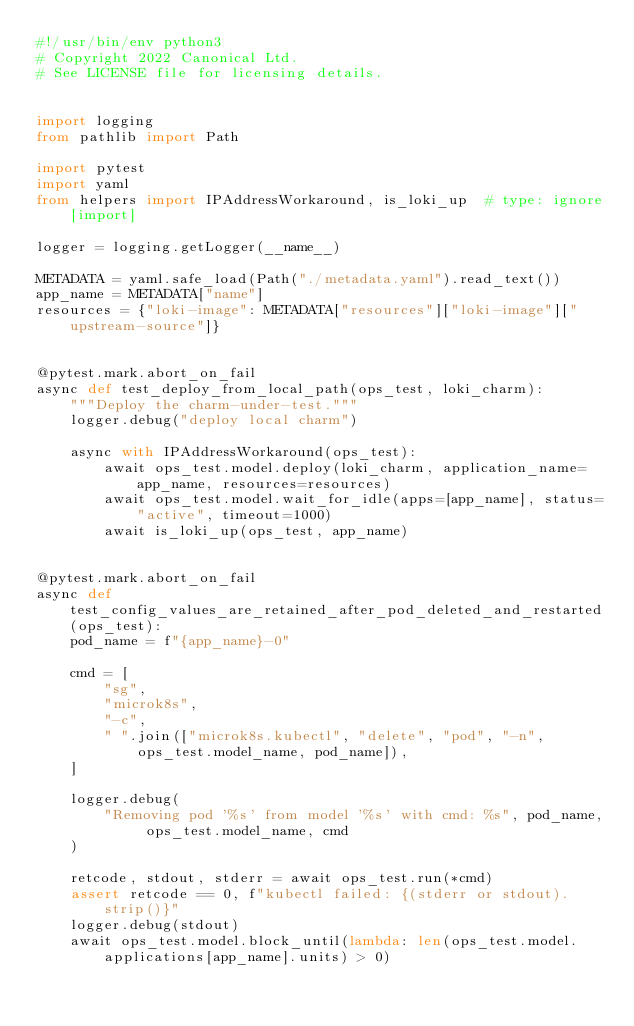Convert code to text. <code><loc_0><loc_0><loc_500><loc_500><_Python_>#!/usr/bin/env python3
# Copyright 2022 Canonical Ltd.
# See LICENSE file for licensing details.


import logging
from pathlib import Path

import pytest
import yaml
from helpers import IPAddressWorkaround, is_loki_up  # type: ignore[import]

logger = logging.getLogger(__name__)

METADATA = yaml.safe_load(Path("./metadata.yaml").read_text())
app_name = METADATA["name"]
resources = {"loki-image": METADATA["resources"]["loki-image"]["upstream-source"]}


@pytest.mark.abort_on_fail
async def test_deploy_from_local_path(ops_test, loki_charm):
    """Deploy the charm-under-test."""
    logger.debug("deploy local charm")

    async with IPAddressWorkaround(ops_test):
        await ops_test.model.deploy(loki_charm, application_name=app_name, resources=resources)
        await ops_test.model.wait_for_idle(apps=[app_name], status="active", timeout=1000)
        await is_loki_up(ops_test, app_name)


@pytest.mark.abort_on_fail
async def test_config_values_are_retained_after_pod_deleted_and_restarted(ops_test):
    pod_name = f"{app_name}-0"

    cmd = [
        "sg",
        "microk8s",
        "-c",
        " ".join(["microk8s.kubectl", "delete", "pod", "-n", ops_test.model_name, pod_name]),
    ]

    logger.debug(
        "Removing pod '%s' from model '%s' with cmd: %s", pod_name, ops_test.model_name, cmd
    )

    retcode, stdout, stderr = await ops_test.run(*cmd)
    assert retcode == 0, f"kubectl failed: {(stderr or stdout).strip()}"
    logger.debug(stdout)
    await ops_test.model.block_until(lambda: len(ops_test.model.applications[app_name].units) > 0)</code> 